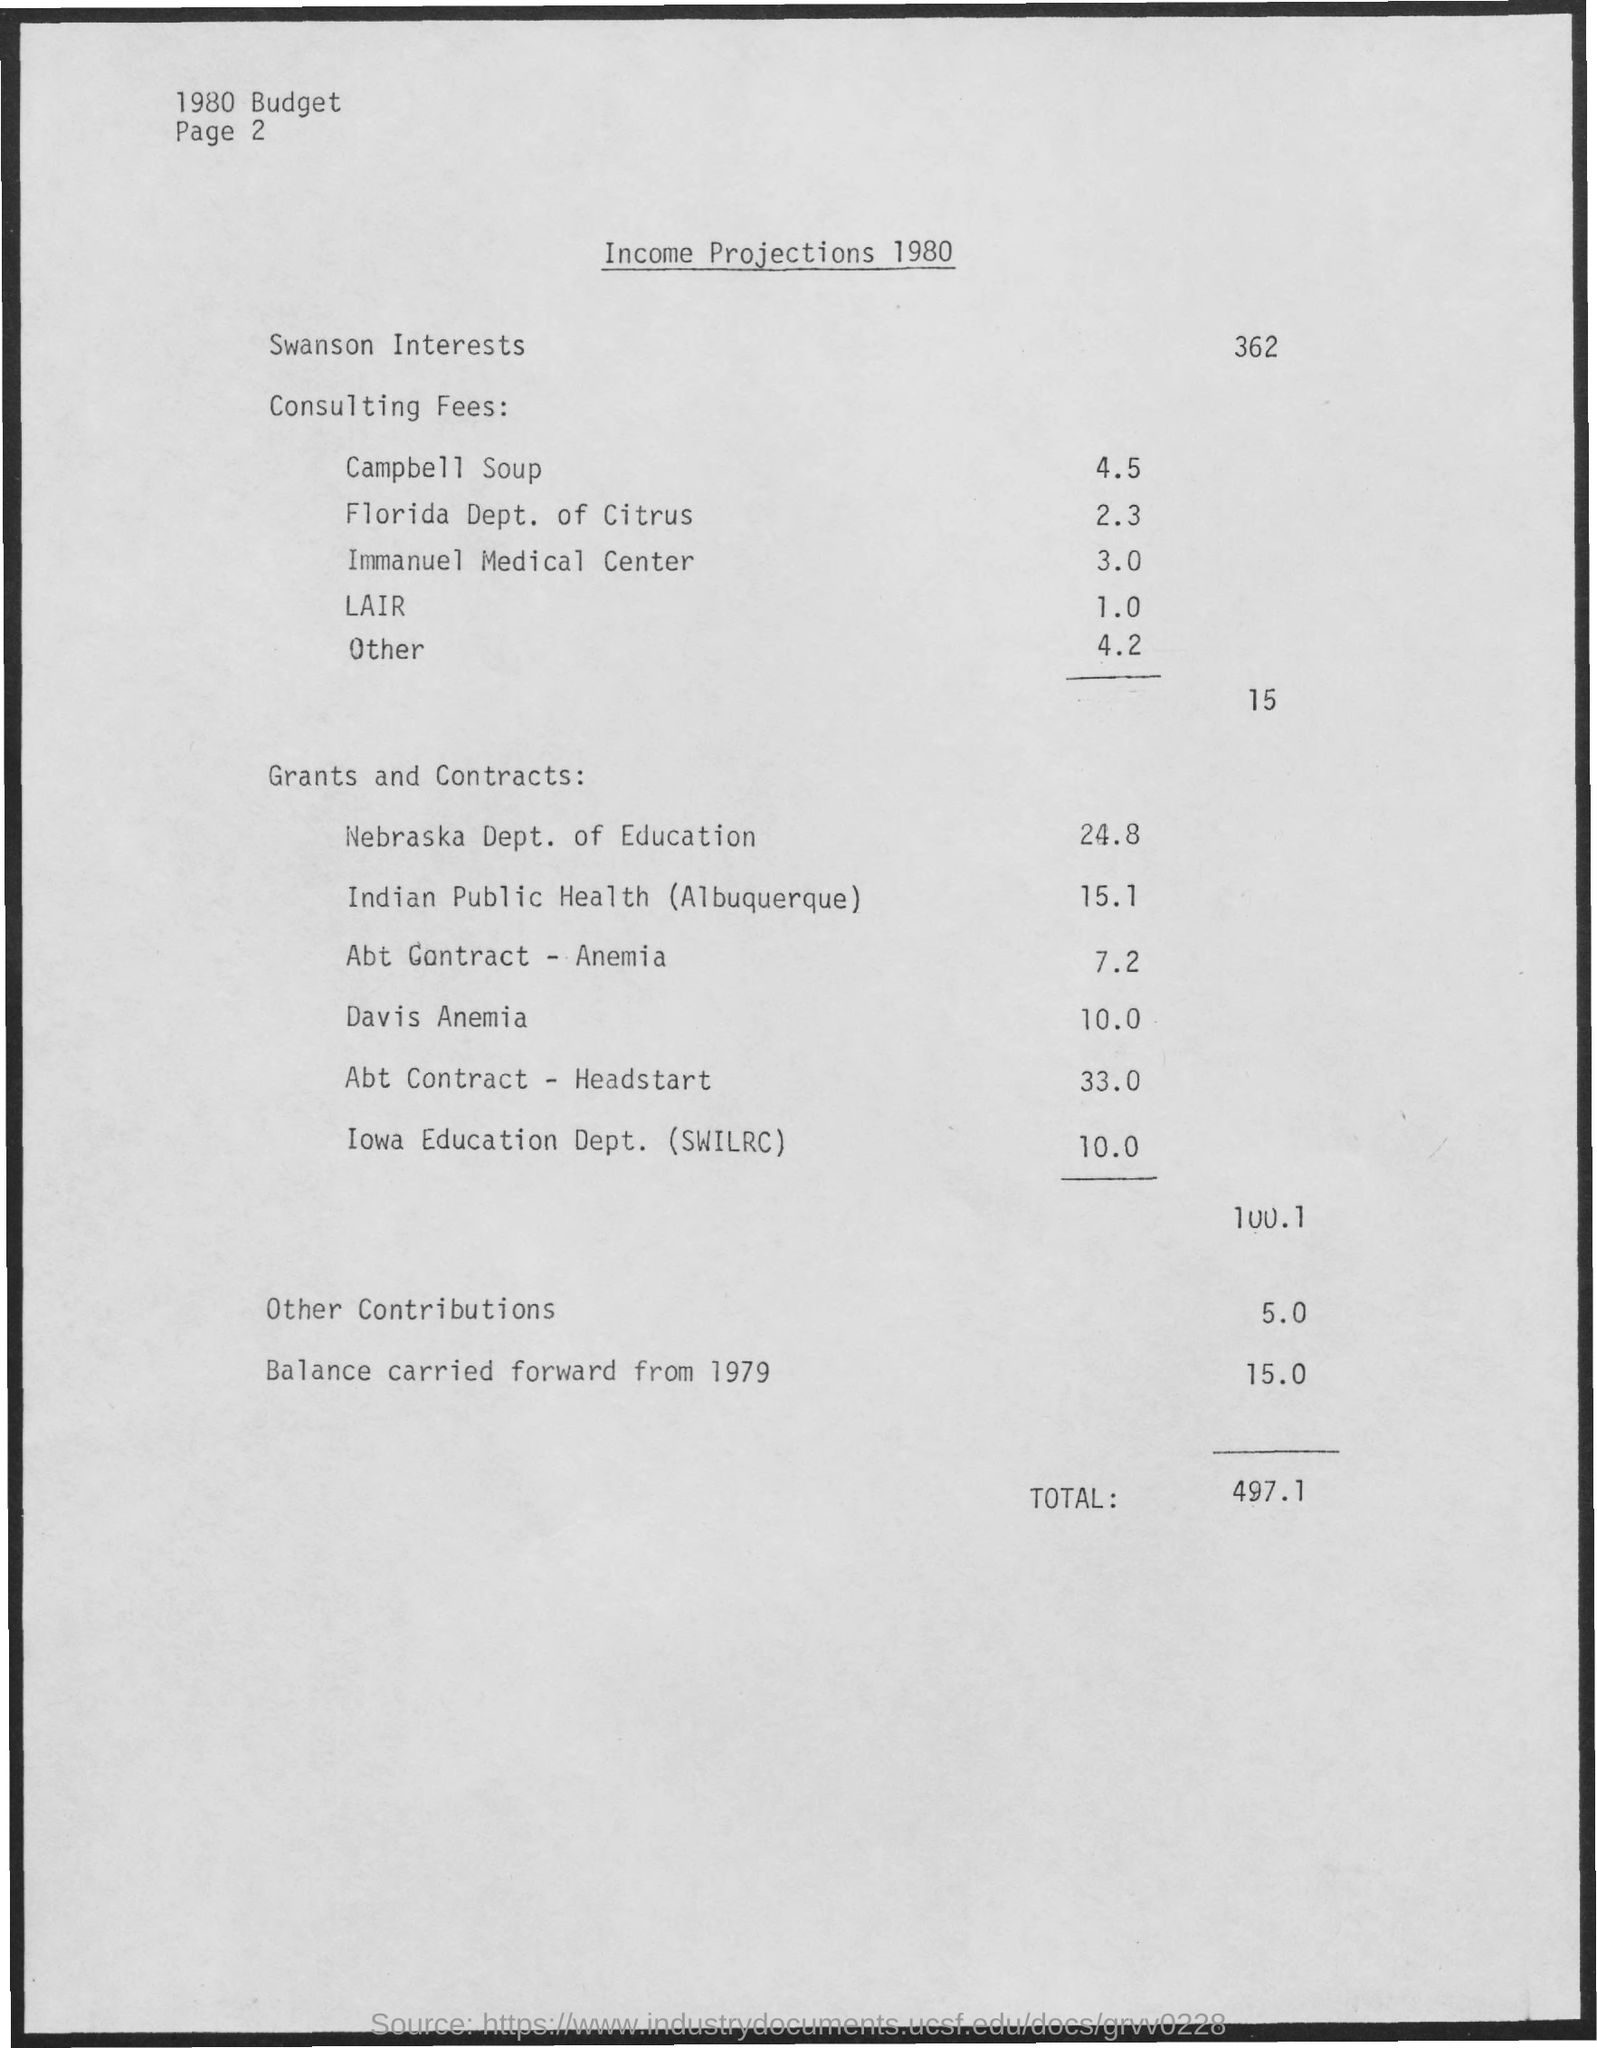Indicate a few pertinent items in this graphic. The amount of income mentioned for the Nebraska Department of Education is $24.8 million. Campbell Soup has been mentioned to have an amount of 4.5. The income from 1979, which was carried forward, is still present. The amount mentioned for the Florida Department of Citrus is 2.3. The total income mentioned is 497.1. 